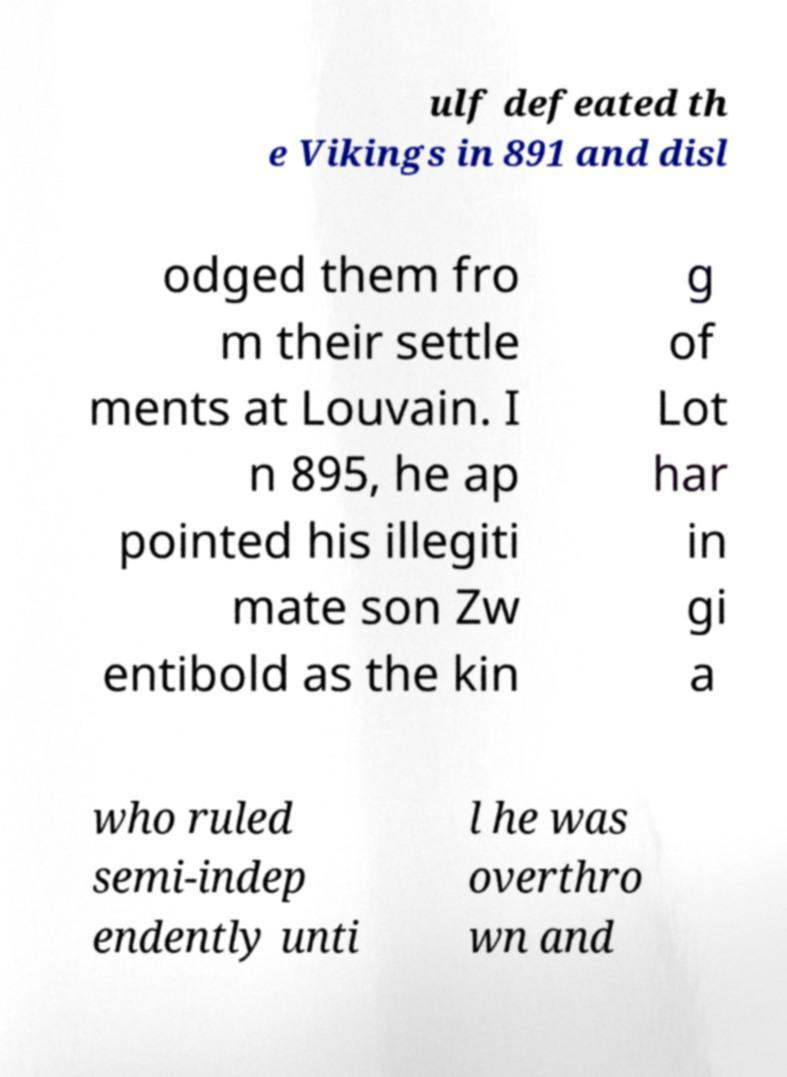Please identify and transcribe the text found in this image. ulf defeated th e Vikings in 891 and disl odged them fro m their settle ments at Louvain. I n 895, he ap pointed his illegiti mate son Zw entibold as the kin g of Lot har in gi a who ruled semi-indep endently unti l he was overthro wn and 